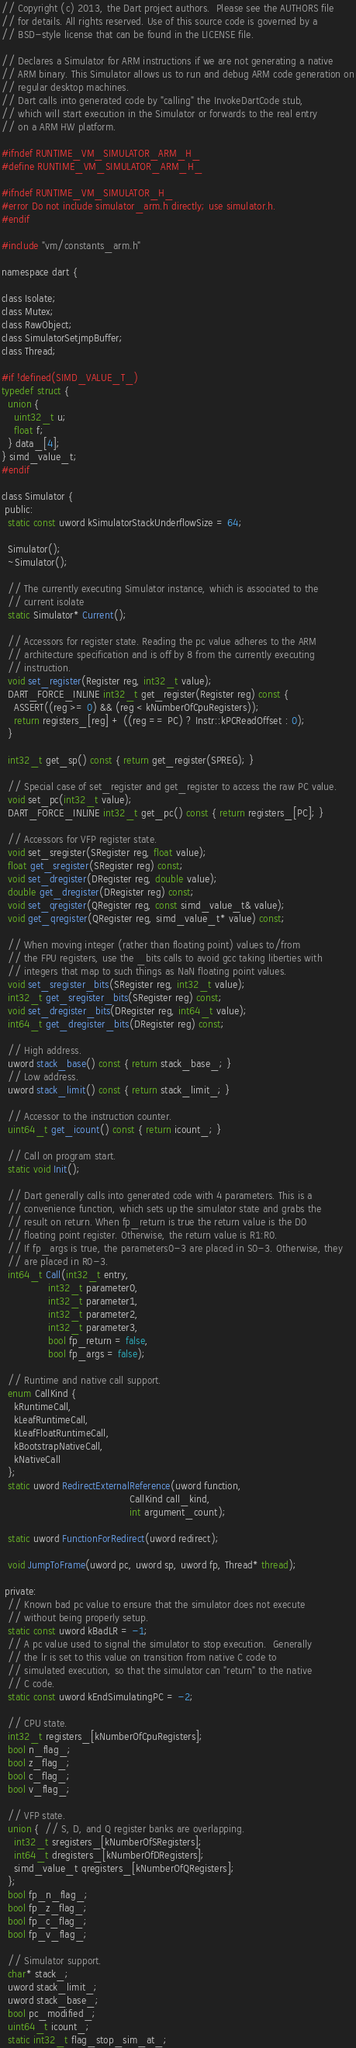<code> <loc_0><loc_0><loc_500><loc_500><_C_>// Copyright (c) 2013, the Dart project authors.  Please see the AUTHORS file
// for details. All rights reserved. Use of this source code is governed by a
// BSD-style license that can be found in the LICENSE file.

// Declares a Simulator for ARM instructions if we are not generating a native
// ARM binary. This Simulator allows us to run and debug ARM code generation on
// regular desktop machines.
// Dart calls into generated code by "calling" the InvokeDartCode stub,
// which will start execution in the Simulator or forwards to the real entry
// on a ARM HW platform.

#ifndef RUNTIME_VM_SIMULATOR_ARM_H_
#define RUNTIME_VM_SIMULATOR_ARM_H_

#ifndef RUNTIME_VM_SIMULATOR_H_
#error Do not include simulator_arm.h directly; use simulator.h.
#endif

#include "vm/constants_arm.h"

namespace dart {

class Isolate;
class Mutex;
class RawObject;
class SimulatorSetjmpBuffer;
class Thread;

#if !defined(SIMD_VALUE_T_)
typedef struct {
  union {
    uint32_t u;
    float f;
  } data_[4];
} simd_value_t;
#endif

class Simulator {
 public:
  static const uword kSimulatorStackUnderflowSize = 64;

  Simulator();
  ~Simulator();

  // The currently executing Simulator instance, which is associated to the
  // current isolate
  static Simulator* Current();

  // Accessors for register state. Reading the pc value adheres to the ARM
  // architecture specification and is off by 8 from the currently executing
  // instruction.
  void set_register(Register reg, int32_t value);
  DART_FORCE_INLINE int32_t get_register(Register reg) const {
    ASSERT((reg >= 0) && (reg < kNumberOfCpuRegisters));
    return registers_[reg] + ((reg == PC) ? Instr::kPCReadOffset : 0);
  }

  int32_t get_sp() const { return get_register(SPREG); }

  // Special case of set_register and get_register to access the raw PC value.
  void set_pc(int32_t value);
  DART_FORCE_INLINE int32_t get_pc() const { return registers_[PC]; }

  // Accessors for VFP register state.
  void set_sregister(SRegister reg, float value);
  float get_sregister(SRegister reg) const;
  void set_dregister(DRegister reg, double value);
  double get_dregister(DRegister reg) const;
  void set_qregister(QRegister reg, const simd_value_t& value);
  void get_qregister(QRegister reg, simd_value_t* value) const;

  // When moving integer (rather than floating point) values to/from
  // the FPU registers, use the _bits calls to avoid gcc taking liberties with
  // integers that map to such things as NaN floating point values.
  void set_sregister_bits(SRegister reg, int32_t value);
  int32_t get_sregister_bits(SRegister reg) const;
  void set_dregister_bits(DRegister reg, int64_t value);
  int64_t get_dregister_bits(DRegister reg) const;

  // High address.
  uword stack_base() const { return stack_base_; }
  // Low address.
  uword stack_limit() const { return stack_limit_; }

  // Accessor to the instruction counter.
  uint64_t get_icount() const { return icount_; }

  // Call on program start.
  static void Init();

  // Dart generally calls into generated code with 4 parameters. This is a
  // convenience function, which sets up the simulator state and grabs the
  // result on return. When fp_return is true the return value is the D0
  // floating point register. Otherwise, the return value is R1:R0.
  // If fp_args is true, the parameters0-3 are placed in S0-3. Otherwise, they
  // are placed in R0-3.
  int64_t Call(int32_t entry,
               int32_t parameter0,
               int32_t parameter1,
               int32_t parameter2,
               int32_t parameter3,
               bool fp_return = false,
               bool fp_args = false);

  // Runtime and native call support.
  enum CallKind {
    kRuntimeCall,
    kLeafRuntimeCall,
    kLeafFloatRuntimeCall,
    kBootstrapNativeCall,
    kNativeCall
  };
  static uword RedirectExternalReference(uword function,
                                         CallKind call_kind,
                                         int argument_count);

  static uword FunctionForRedirect(uword redirect);

  void JumpToFrame(uword pc, uword sp, uword fp, Thread* thread);

 private:
  // Known bad pc value to ensure that the simulator does not execute
  // without being properly setup.
  static const uword kBadLR = -1;
  // A pc value used to signal the simulator to stop execution.  Generally
  // the lr is set to this value on transition from native C code to
  // simulated execution, so that the simulator can "return" to the native
  // C code.
  static const uword kEndSimulatingPC = -2;

  // CPU state.
  int32_t registers_[kNumberOfCpuRegisters];
  bool n_flag_;
  bool z_flag_;
  bool c_flag_;
  bool v_flag_;

  // VFP state.
  union {  // S, D, and Q register banks are overlapping.
    int32_t sregisters_[kNumberOfSRegisters];
    int64_t dregisters_[kNumberOfDRegisters];
    simd_value_t qregisters_[kNumberOfQRegisters];
  };
  bool fp_n_flag_;
  bool fp_z_flag_;
  bool fp_c_flag_;
  bool fp_v_flag_;

  // Simulator support.
  char* stack_;
  uword stack_limit_;
  uword stack_base_;
  bool pc_modified_;
  uint64_t icount_;
  static int32_t flag_stop_sim_at_;</code> 